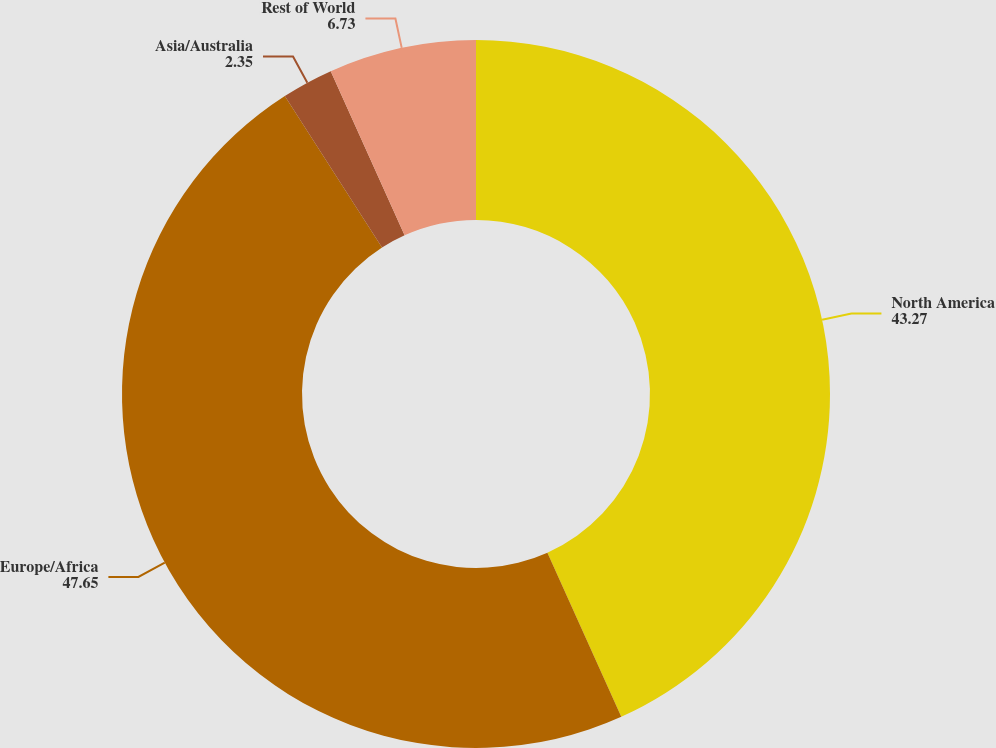Convert chart to OTSL. <chart><loc_0><loc_0><loc_500><loc_500><pie_chart><fcel>North America<fcel>Europe/Africa<fcel>Asia/Australia<fcel>Rest of World<nl><fcel>43.27%<fcel>47.65%<fcel>2.35%<fcel>6.73%<nl></chart> 